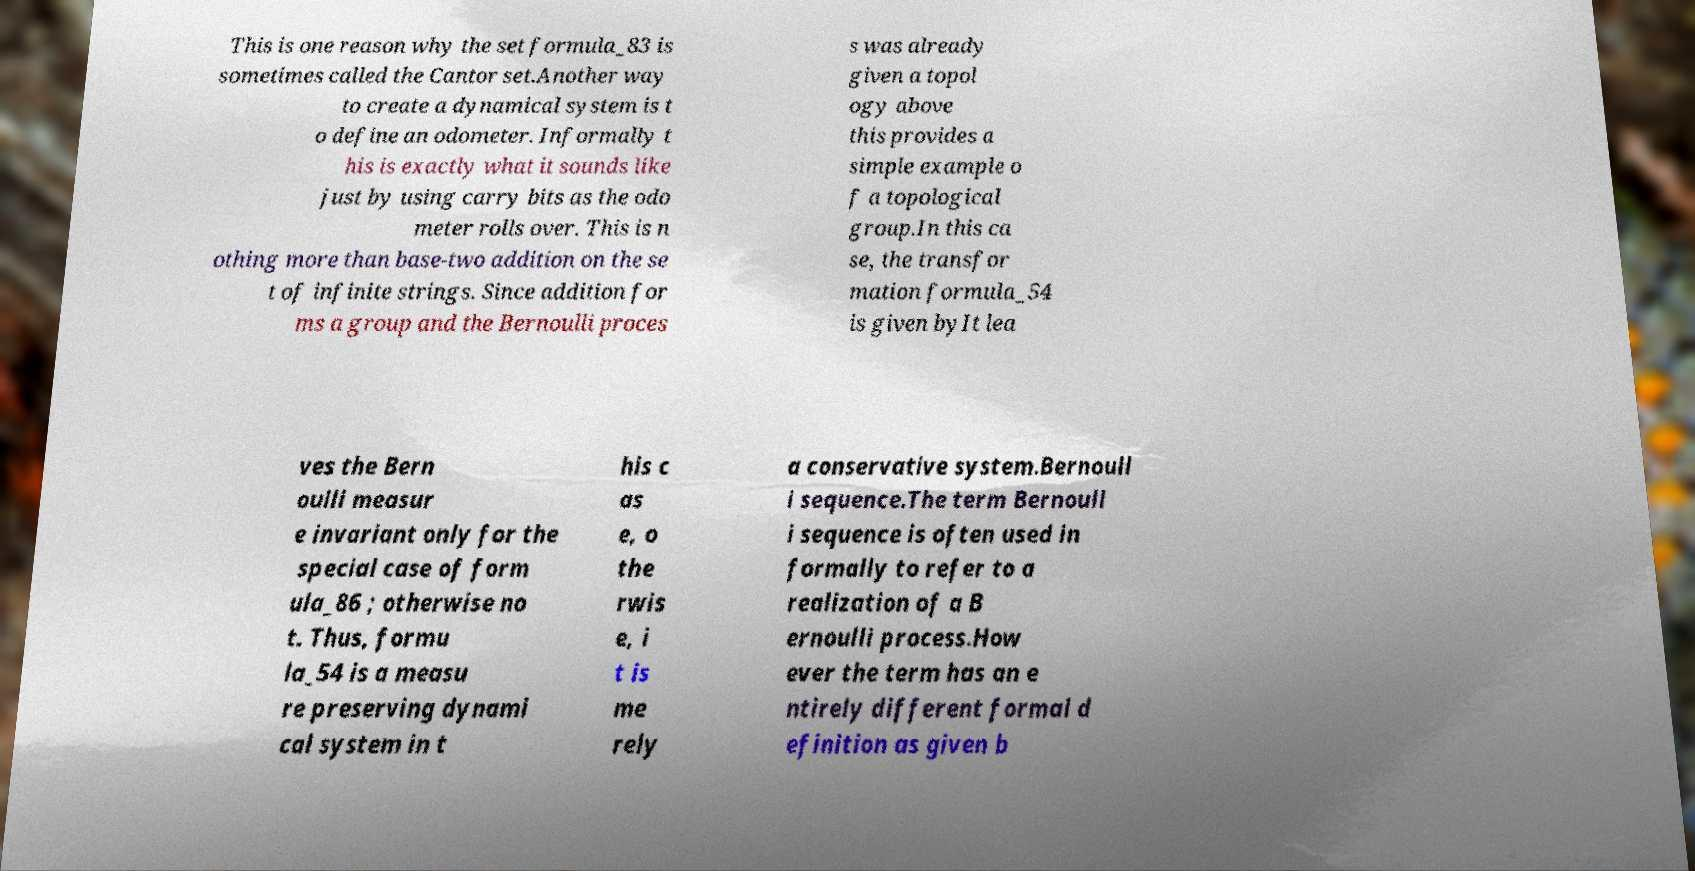Could you assist in decoding the text presented in this image and type it out clearly? This is one reason why the set formula_83 is sometimes called the Cantor set.Another way to create a dynamical system is t o define an odometer. Informally t his is exactly what it sounds like just by using carry bits as the odo meter rolls over. This is n othing more than base-two addition on the se t of infinite strings. Since addition for ms a group and the Bernoulli proces s was already given a topol ogy above this provides a simple example o f a topological group.In this ca se, the transfor mation formula_54 is given byIt lea ves the Bern oulli measur e invariant only for the special case of form ula_86 ; otherwise no t. Thus, formu la_54 is a measu re preserving dynami cal system in t his c as e, o the rwis e, i t is me rely a conservative system.Bernoull i sequence.The term Bernoull i sequence is often used in formally to refer to a realization of a B ernoulli process.How ever the term has an e ntirely different formal d efinition as given b 